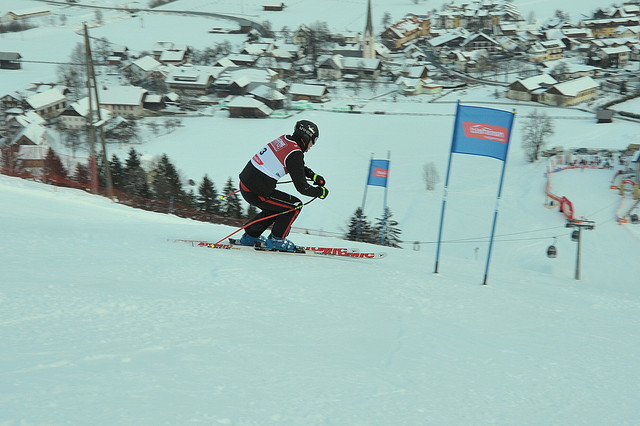<image>What is the name of the ski trail? It is not possible to know the name of the ski trail. It could be 'alpine', 'bear mountain', 'eddie bauer', 'aspen', 'westlake', 'geoffrion', 'professional', or 'ski resort'. What is the name of the ski trail? I don't know the name of the ski trail. It can be any of ['alpine', 'bear mountain', 'eddie bauer', 'aspen', 'westlake', 'geoffrion', 'professional', 'none', 'ski resort']. 